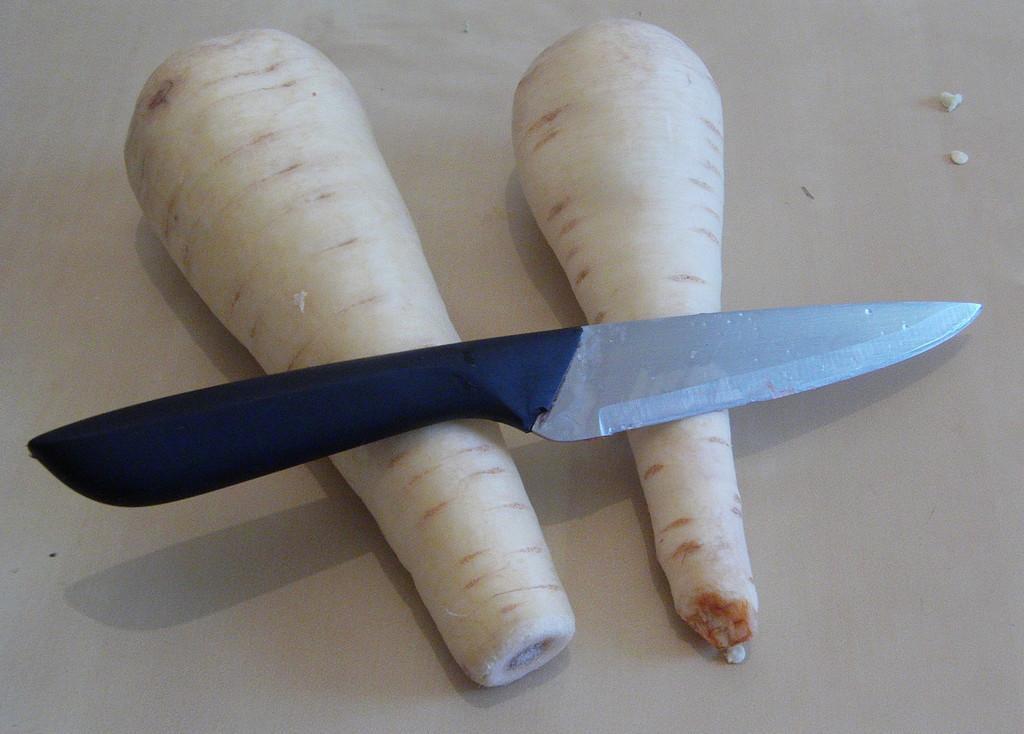Could you give a brief overview of what you see in this image? In this picture I can see there are two radish placed on a surface and there is a knife placed on it. The knife has a black handle. 